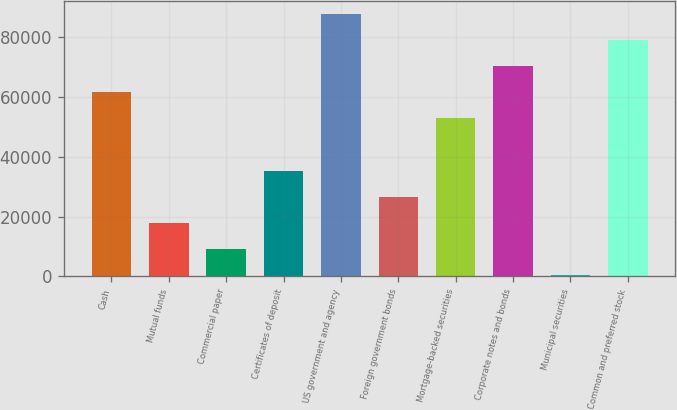<chart> <loc_0><loc_0><loc_500><loc_500><bar_chart><fcel>Cash<fcel>Mutual funds<fcel>Commercial paper<fcel>Certificates of deposit<fcel>US government and agency<fcel>Foreign government bonds<fcel>Mortgage-backed securities<fcel>Corporate notes and bonds<fcel>Municipal securities<fcel>Common and preferred stock<nl><fcel>61621.7<fcel>17881.2<fcel>9133.1<fcel>35377.4<fcel>87866<fcel>26629.3<fcel>52873.6<fcel>70369.8<fcel>385<fcel>79117.9<nl></chart> 